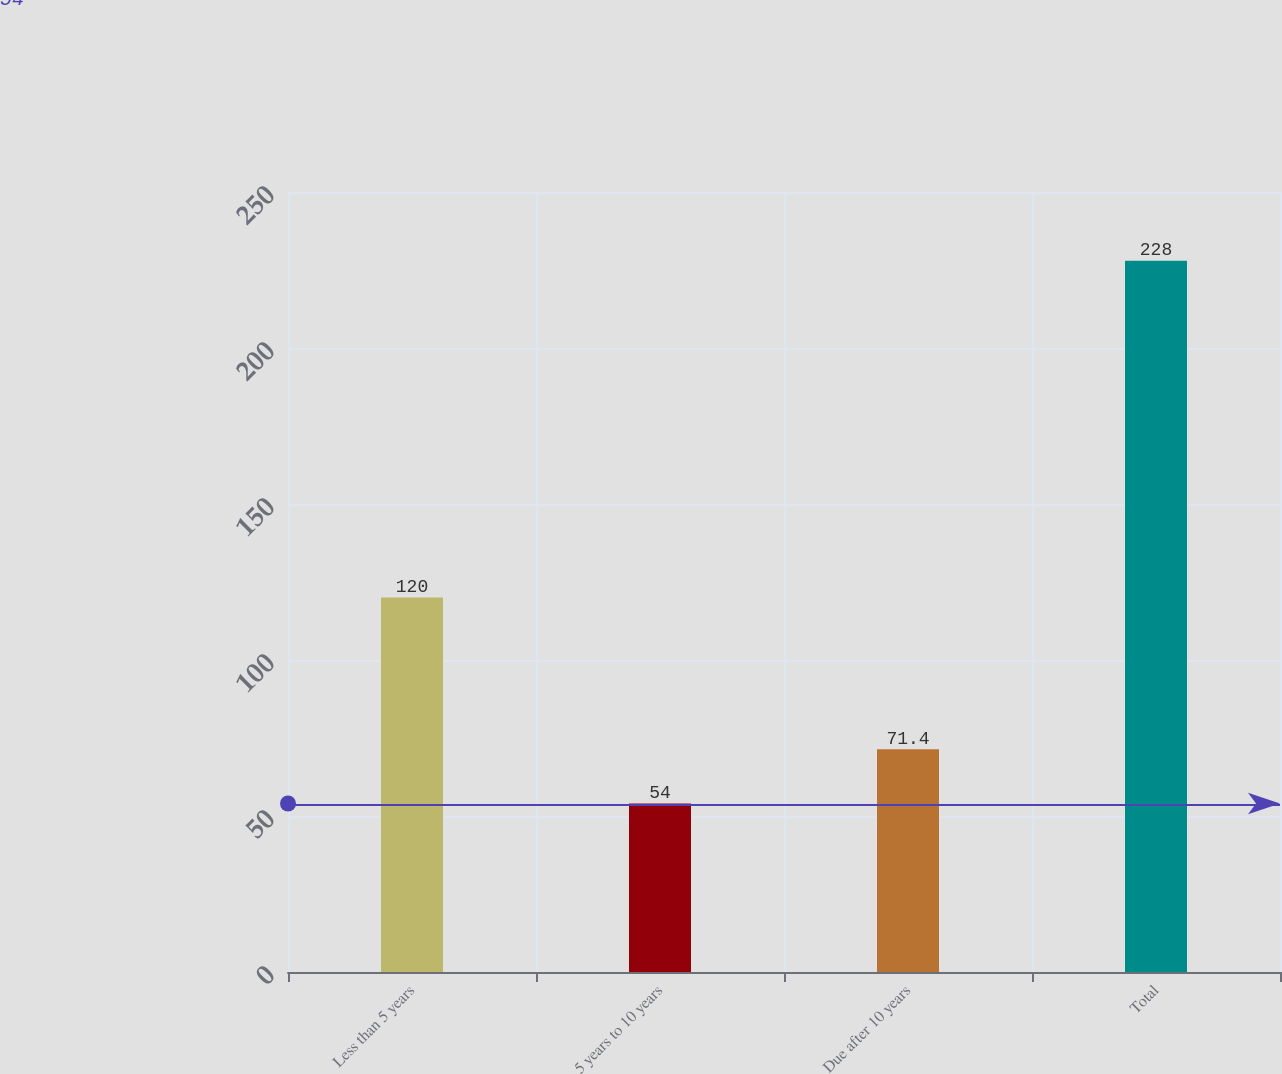Convert chart. <chart><loc_0><loc_0><loc_500><loc_500><bar_chart><fcel>Less than 5 years<fcel>5 years to 10 years<fcel>Due after 10 years<fcel>Total<nl><fcel>120<fcel>54<fcel>71.4<fcel>228<nl></chart> 